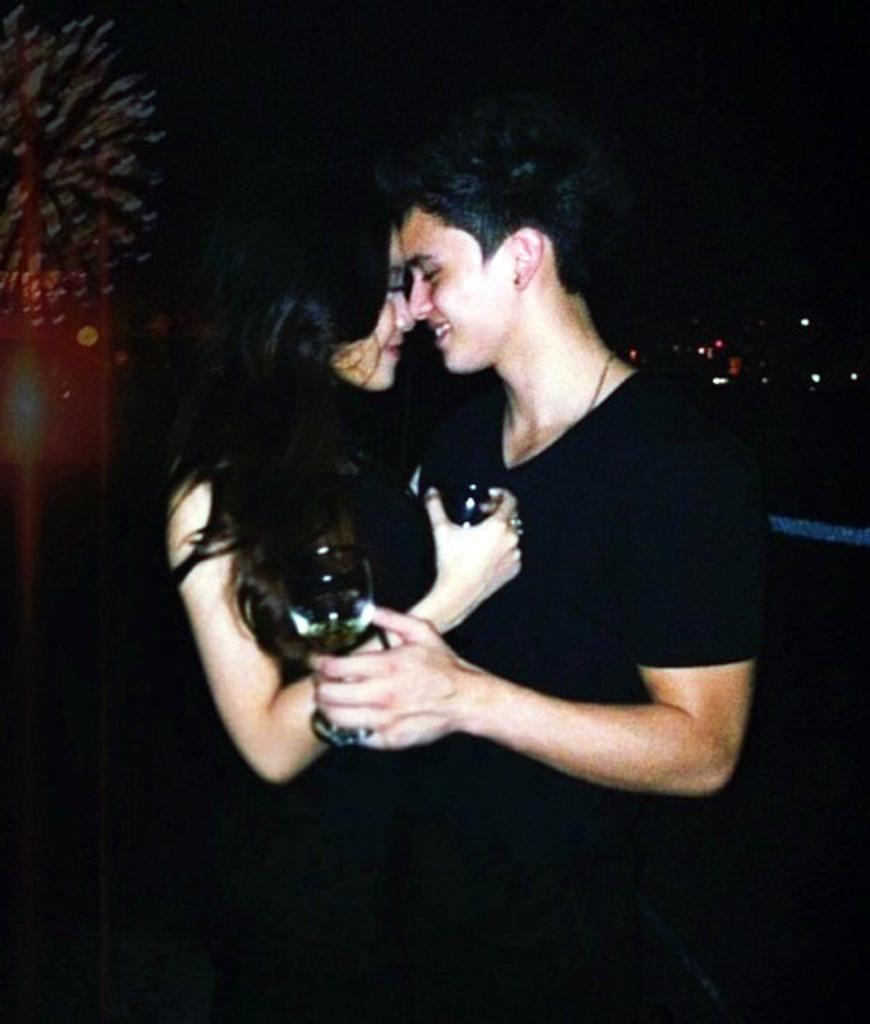Who is present in the image? There is a couple in the image. What are the couple wearing? The couple is wearing black dress. What are the couple holding in their hands? The couple is holding glasses. What can be seen in the background of the image? There are lights in the background of the image. How would you describe the overall lighting in the image? The background is dark. What type of battle is taking place in the background of the image? There is no battle present in the image; the background features lights and a dark setting. Is this image taken in a bedroom? The provided facts do not mention a bedroom, so it cannot be determined from the image. 